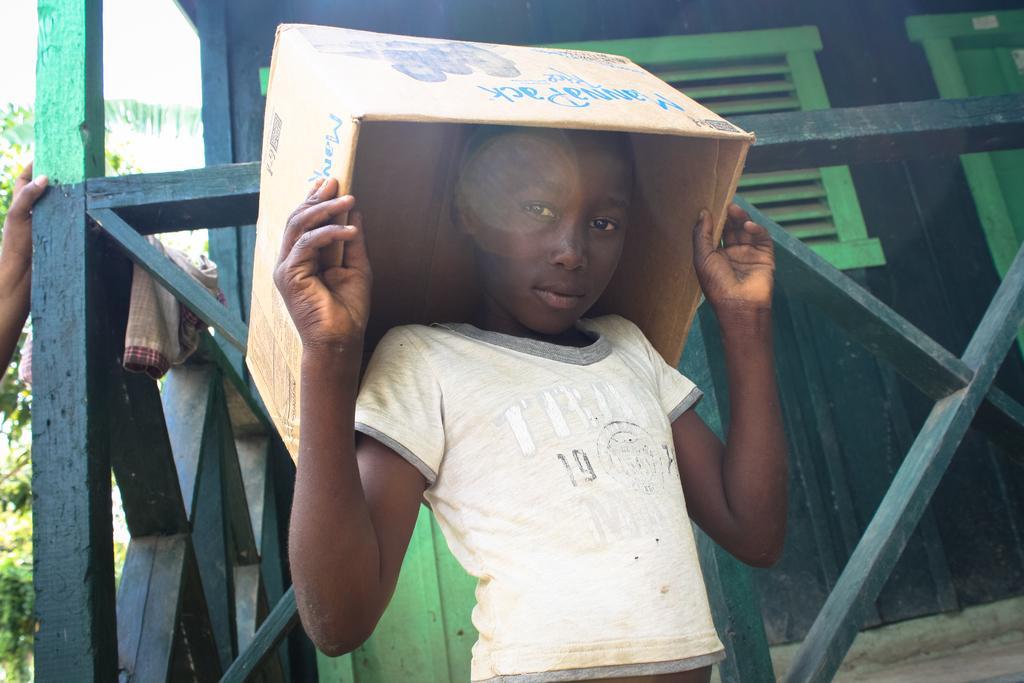Could you give a brief overview of what you see in this image? In this picture there is a small boy in the center of the image, by holding a box over his head, there are trees on the left side of the image and there is a wooden boundary in the background area of the image. 